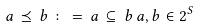<formula> <loc_0><loc_0><loc_500><loc_500>a \, \preceq \, b \, \colon = \, a \, \subseteq \, b \, a , b \in 2 ^ { S }</formula> 